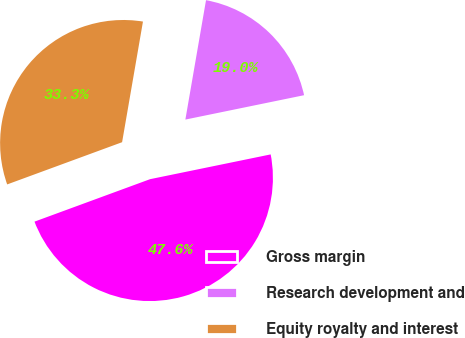Convert chart. <chart><loc_0><loc_0><loc_500><loc_500><pie_chart><fcel>Gross margin<fcel>Research development and<fcel>Equity royalty and interest<nl><fcel>47.62%<fcel>19.05%<fcel>33.33%<nl></chart> 